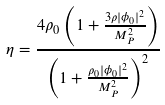<formula> <loc_0><loc_0><loc_500><loc_500>\eta = \frac { 4 \rho _ { 0 } \left ( 1 + \frac { 3 \rho | \phi _ { 0 } | ^ { 2 } } { M _ { P } ^ { 2 } } \right ) } { \left ( 1 + \frac { \rho _ { 0 } | \phi _ { 0 } | ^ { 2 } } { M _ { P } ^ { 2 } } \right ) ^ { 2 } }</formula> 